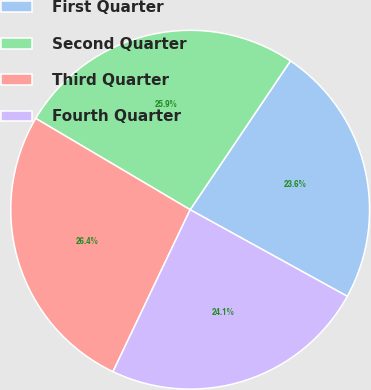Convert chart to OTSL. <chart><loc_0><loc_0><loc_500><loc_500><pie_chart><fcel>First Quarter<fcel>Second Quarter<fcel>Third Quarter<fcel>Fourth Quarter<nl><fcel>23.58%<fcel>25.94%<fcel>26.42%<fcel>24.06%<nl></chart> 